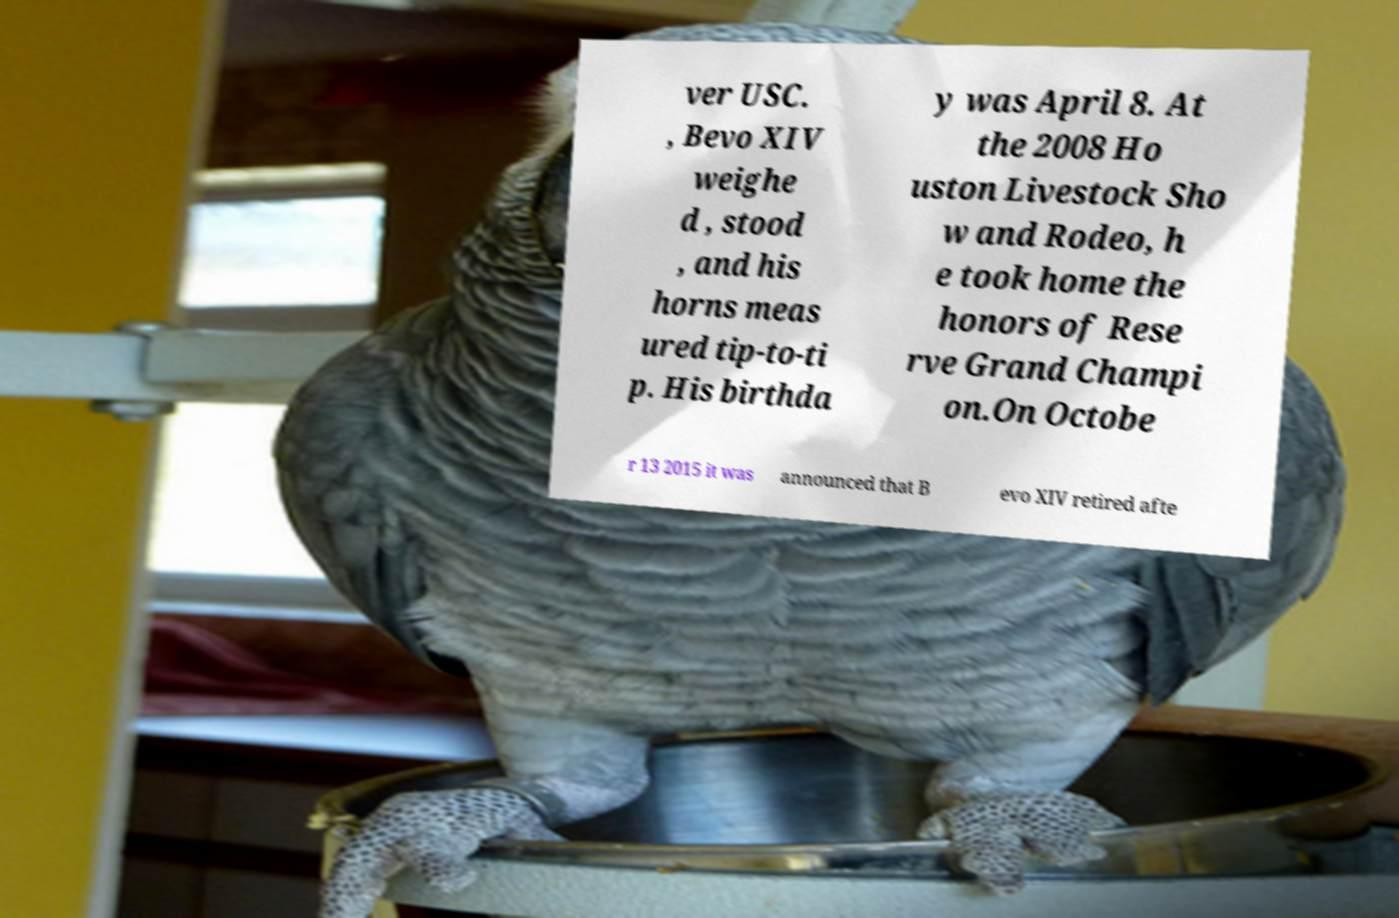Can you read and provide the text displayed in the image?This photo seems to have some interesting text. Can you extract and type it out for me? ver USC. , Bevo XIV weighe d , stood , and his horns meas ured tip-to-ti p. His birthda y was April 8. At the 2008 Ho uston Livestock Sho w and Rodeo, h e took home the honors of Rese rve Grand Champi on.On Octobe r 13 2015 it was announced that B evo XIV retired afte 